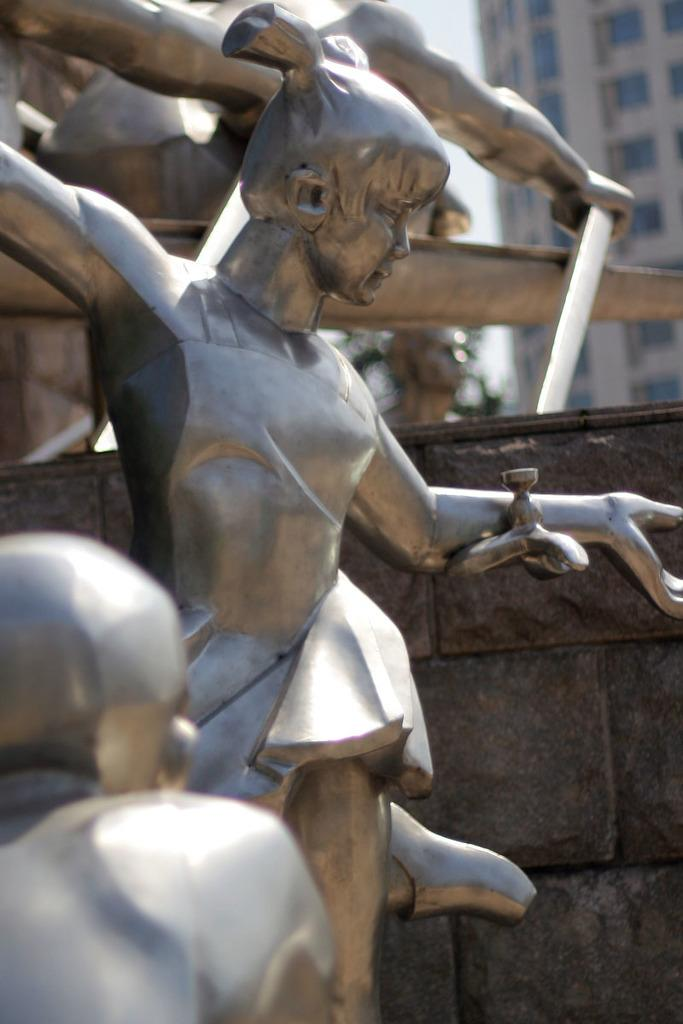What type of objects can be seen in the image? There are statues in the image. What type of structure is visible in the image? There is a building with windows visible in the image. What theory is being discussed in the book held by the statue in the image? There is no book held by the statue in the image, and therefore no theory being discussed. 